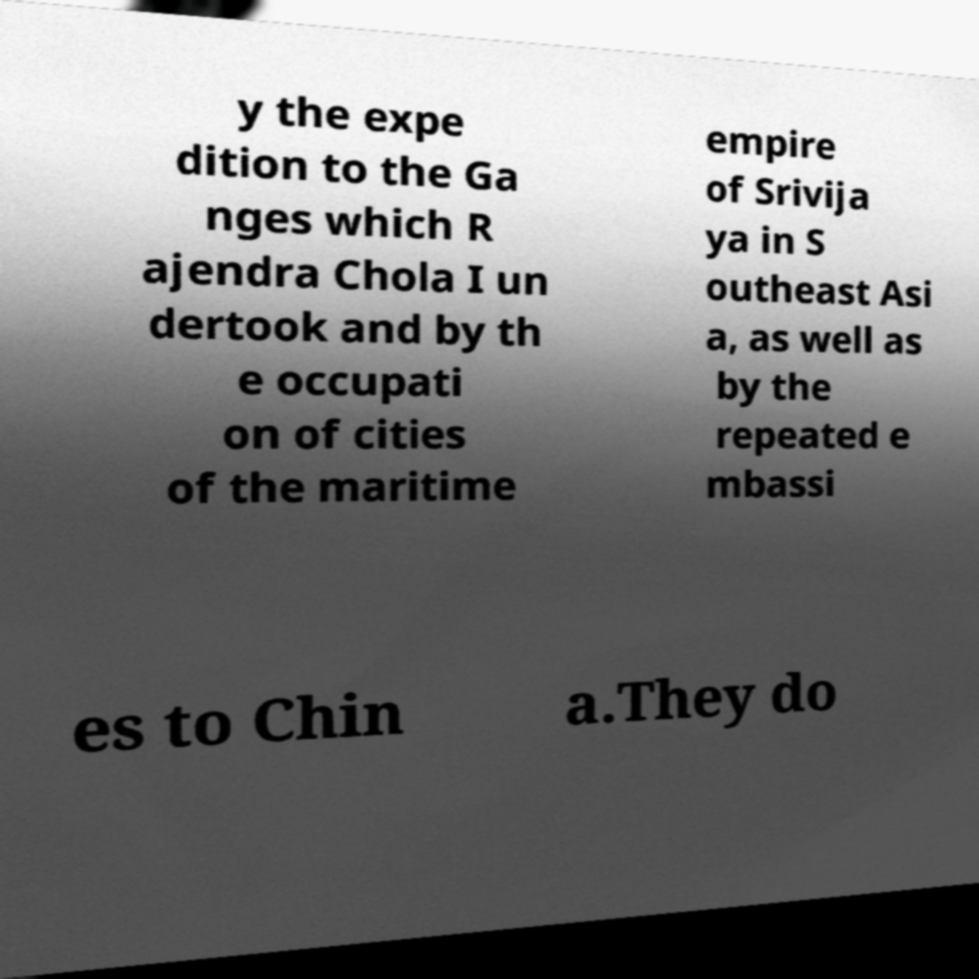There's text embedded in this image that I need extracted. Can you transcribe it verbatim? y the expe dition to the Ga nges which R ajendra Chola I un dertook and by th e occupati on of cities of the maritime empire of Srivija ya in S outheast Asi a, as well as by the repeated e mbassi es to Chin a.They do 